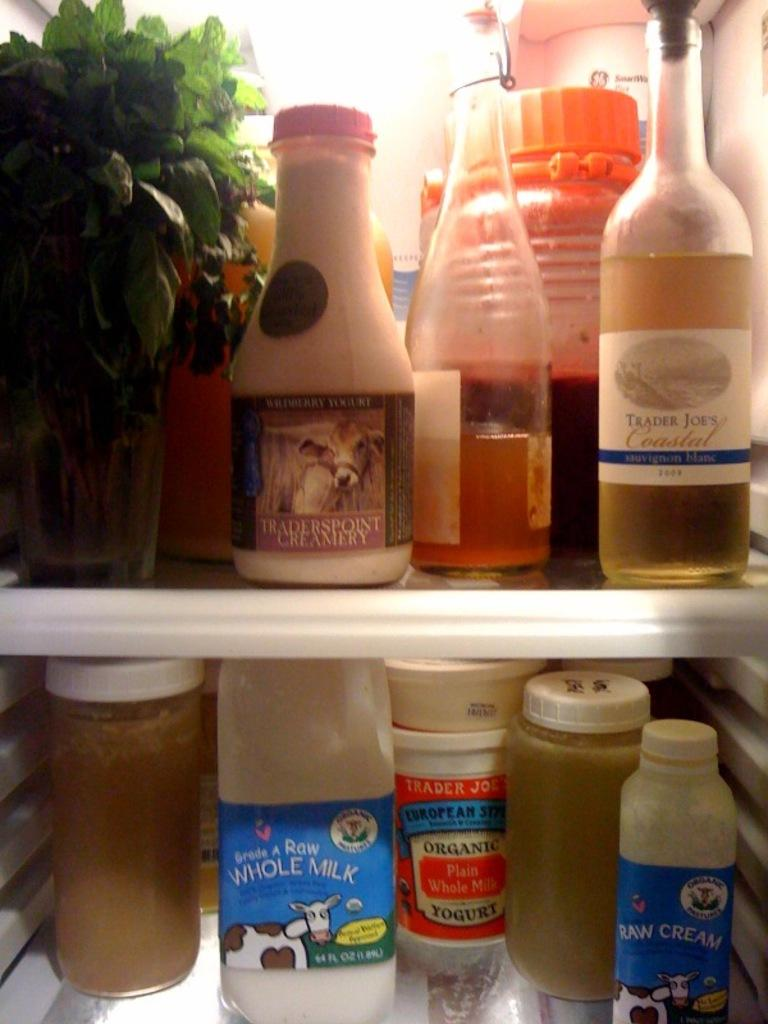What objects can be seen in the image? There are bottles in the image. Where are the bottles located? The bottles are kept on a shelf. What type of nail is being used to hold the bottles in place on the shelf? There is no nail visible in the image, and the bottles are not being held in place by any nail. 